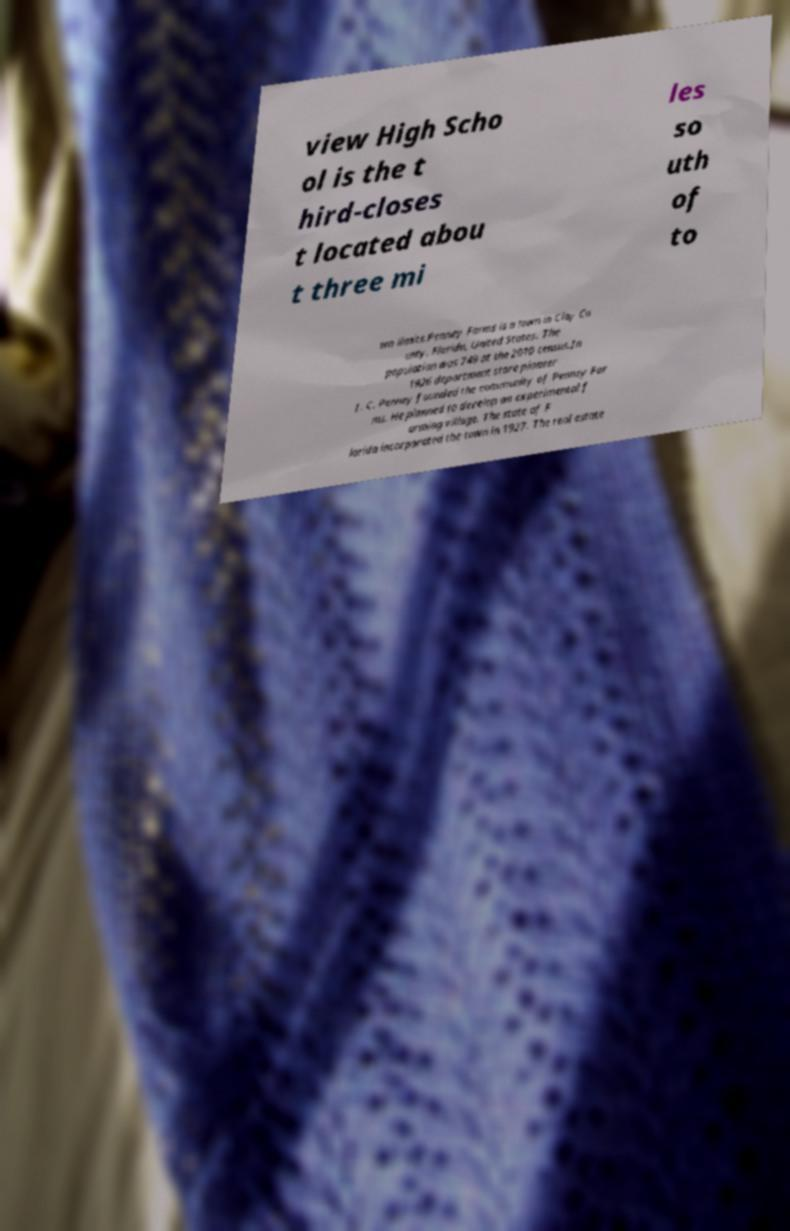I need the written content from this picture converted into text. Can you do that? view High Scho ol is the t hird-closes t located abou t three mi les so uth of to wn limits.Penney Farms is a town in Clay Co unty, Florida, United States. The population was 749 at the 2010 census.In 1926 department store pioneer J. C. Penney founded the community of Penney Far ms. He planned to develop an experimental f arming village. The state of F lorida incorporated the town in 1927. The real estate 